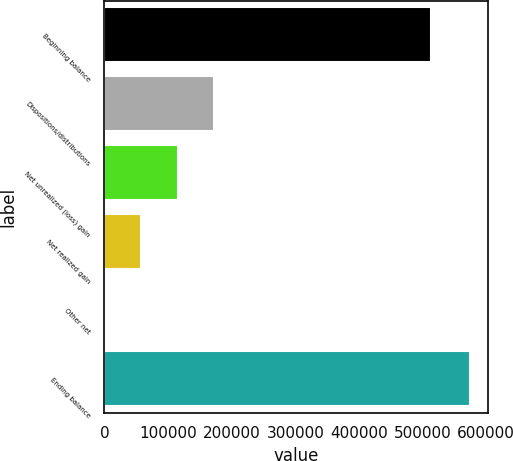<chart> <loc_0><loc_0><loc_500><loc_500><bar_chart><fcel>Beginning balance<fcel>Dispositions/distributions<fcel>Net unrealized (loss) gain<fcel>Net realized gain<fcel>Other net<fcel>Ending balance<nl><fcel>513973<fcel>172795<fcel>115371<fcel>57947.7<fcel>524<fcel>574761<nl></chart> 